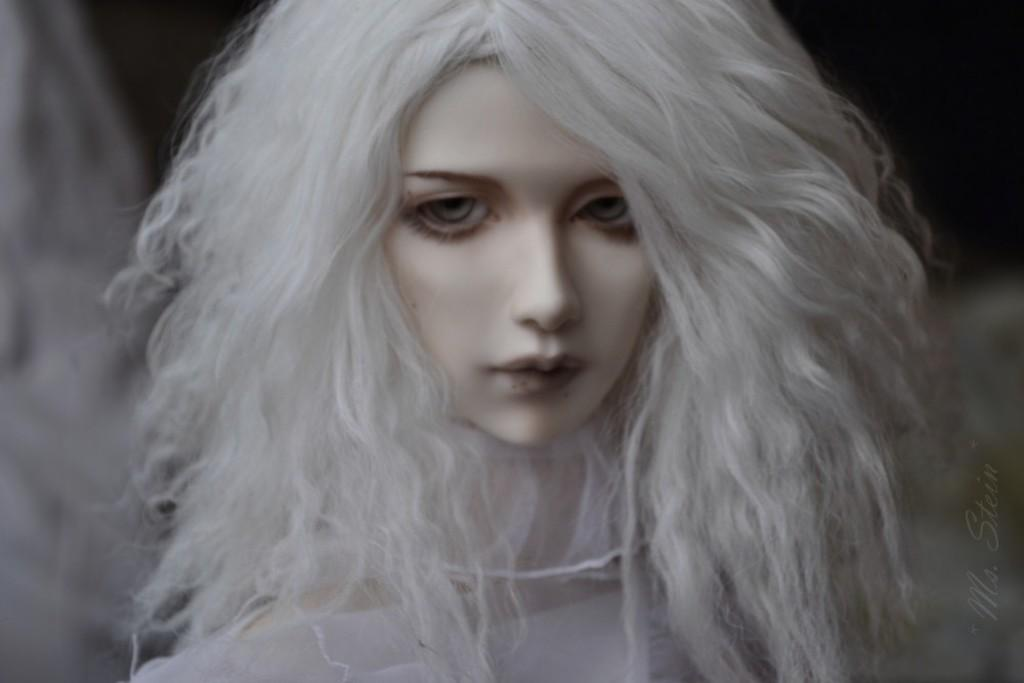What is the main subject of the image? There is a doll in the image. Can you describe the background of the image? The background of the image is blurred. How many legs can be seen on the library in the image? There is no library present in the image, and therefore no legs can be seen on it. 